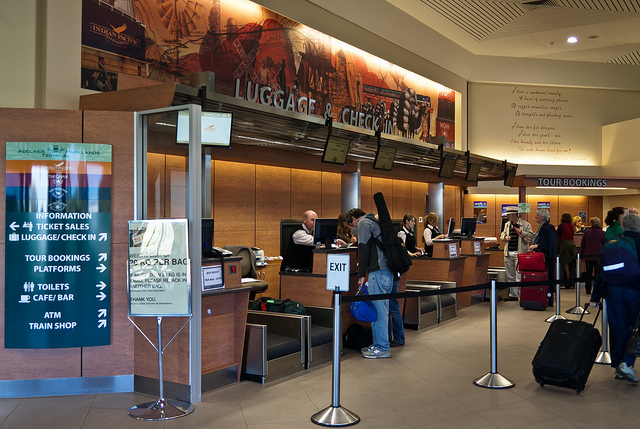What is the mood of the people in the station? Most individuals seem to be engaged in the process of waiting or interacting with the service counter. There are no overt signs of distress or extreme emotions, suggesting a typical, calm environment you'd expect in a public transport hub. 